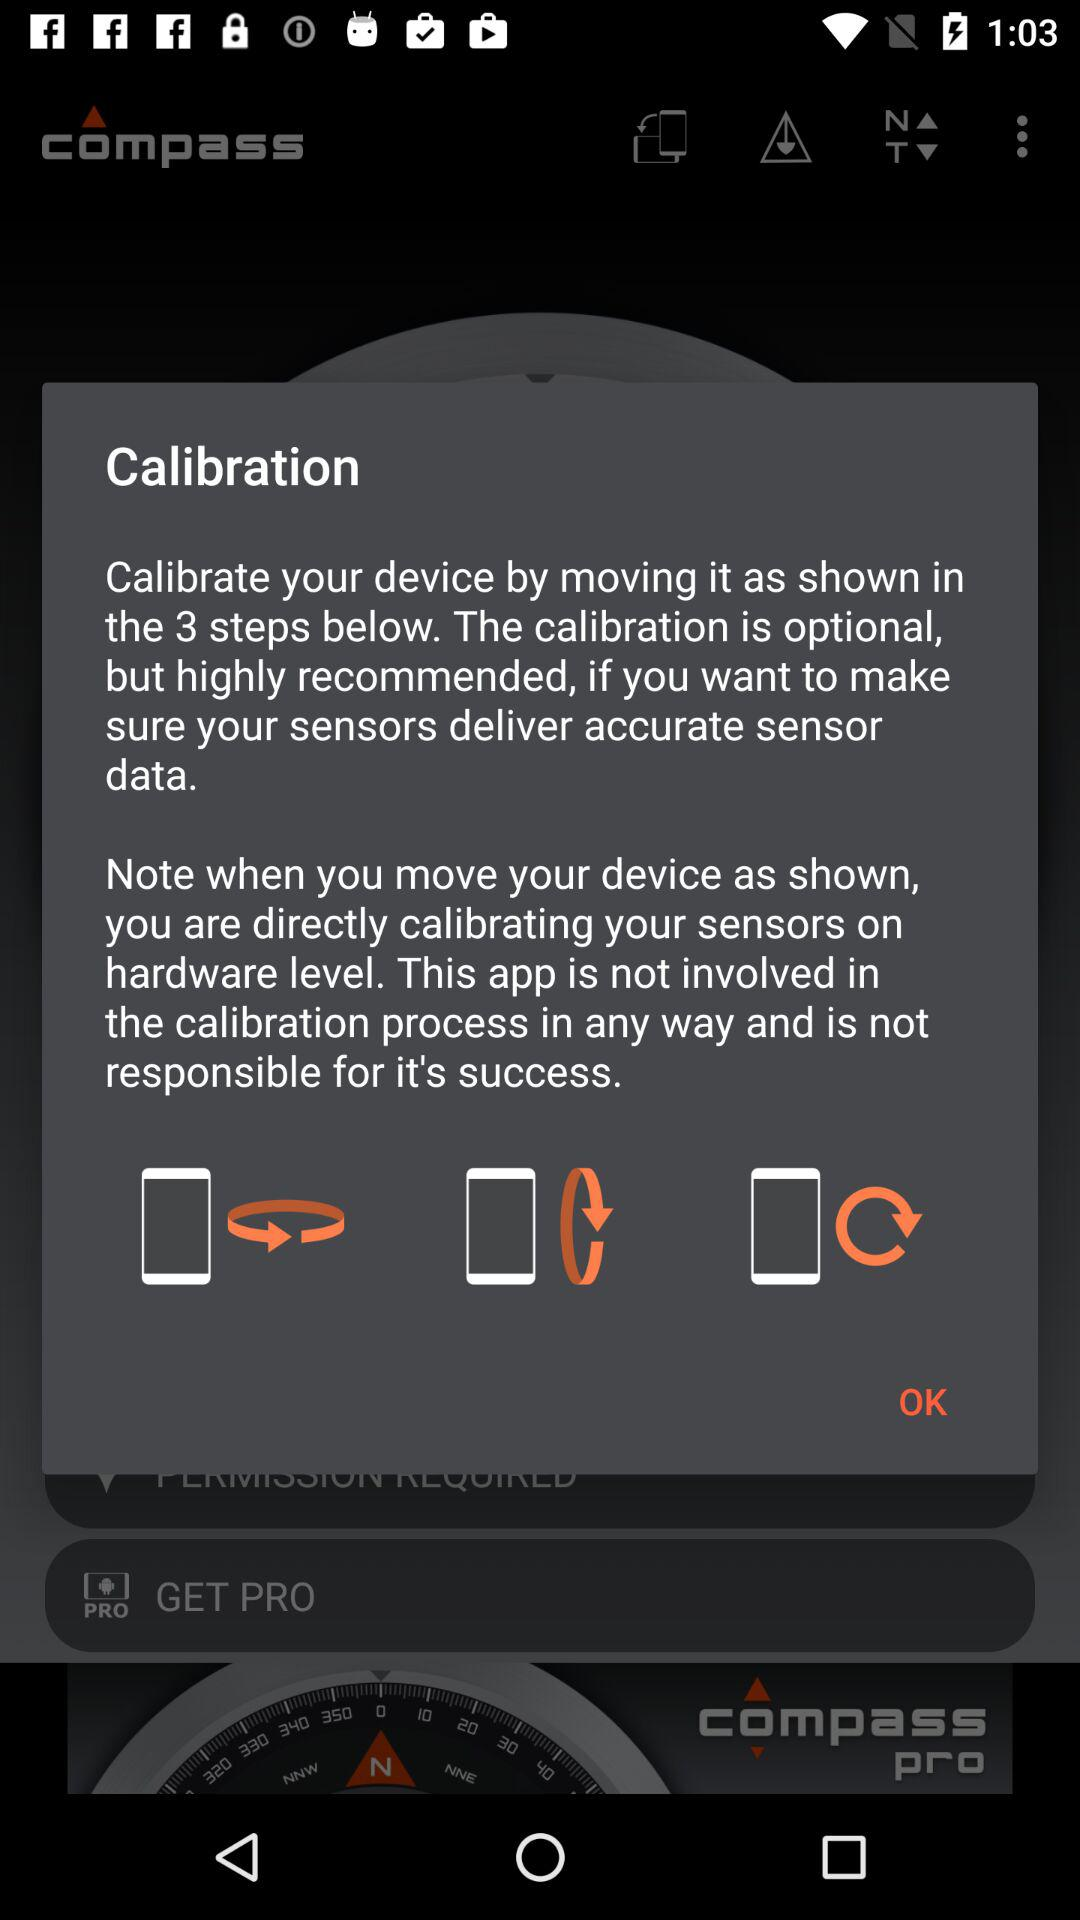How many steps are shown in the instructions?
Answer the question using a single word or phrase. 3 